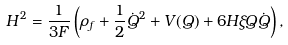Convert formula to latex. <formula><loc_0><loc_0><loc_500><loc_500>H ^ { 2 } = \frac { 1 } { 3 F } \left ( \rho _ { f } + \frac { 1 } { 2 } \dot { Q } ^ { 2 } + V ( Q ) + 6 H \xi Q \dot { Q } \right ) ,</formula> 